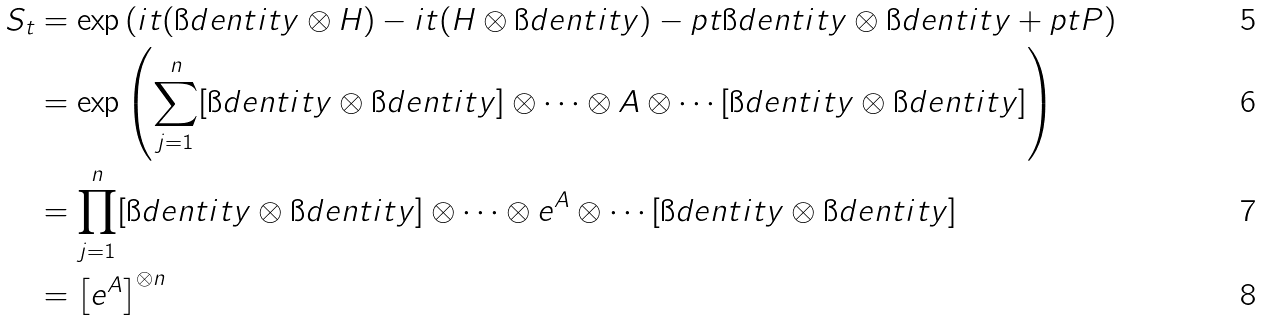Convert formula to latex. <formula><loc_0><loc_0><loc_500><loc_500>S _ { t } & = \exp \left ( i t ( \i d e n t i t y \otimes H ) - i t ( H \otimes \i d e n t i t y ) - p t \i d e n t i t y \otimes \i d e n t i t y + p t P \right ) \\ & = \exp \left ( \sum _ { j = 1 } ^ { n } [ { \i d e n t i t y } \otimes { \i d e n t i t y } ] \otimes \cdots \otimes A \otimes \cdots [ { \i d e n t i t y } \otimes { \i d e n t i t y } ] \right ) \\ & = \prod _ { j = 1 } ^ { n } [ { \i d e n t i t y } \otimes { \i d e n t i t y } ] \otimes \cdots \otimes e ^ { A } \otimes \cdots [ { \i d e n t i t y } \otimes { \i d e n t i t y } ] \\ & = \left [ e ^ { A } \right ] ^ { \otimes n }</formula> 